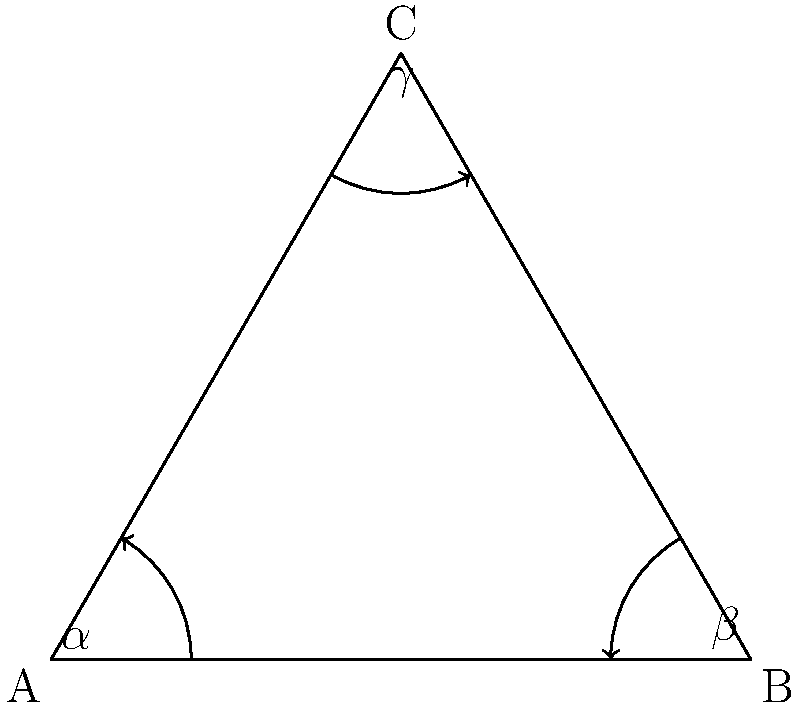In a non-Euclidean political system represented by a hyperbolic triangle, the angles $\alpha$, $\beta$, and $\gamma$ symbolize the power distribution among three political factions. If the sum of these angles is less than 180°, what does this imply about the nature of political power in this system compared to a Euclidean (flat) political landscape? 1. In Euclidean geometry, the sum of angles in a triangle is always 180°. This represents a "balanced" or "zero-sum" political system.

2. In hyperbolic geometry, the sum of angles in a triangle is always less than 180°. This represents a "negative curvature" in the political space.

3. The deficit between the angle sum and 180° is called the defect of the triangle. In political terms, this defect represents "unclaimed" or "distributed" power within the system.

4. A larger defect (smaller angle sum) implies:
   a) More "space" or flexibility in the political system
   b) Potential for emergent political actors or movements
   c) Less concentration of power among the three main factions

5. This non-Euclidean model suggests that political power in this system is not a zero-sum game. As one faction's influence decreases, it doesn't necessarily mean others' influence increases proportionally.

6. The hyperbolic nature implies that coalitions and political maneuvering might have unexpected outcomes, as the "political space" behaves differently from our intuitive Euclidean expectations.

7. This model could represent a more dynamic, less stable political system with opportunities for new ideas or factions to emerge and influence the overall power structure.
Answer: More distributed power, increased political flexibility, and potential for emergent actors 